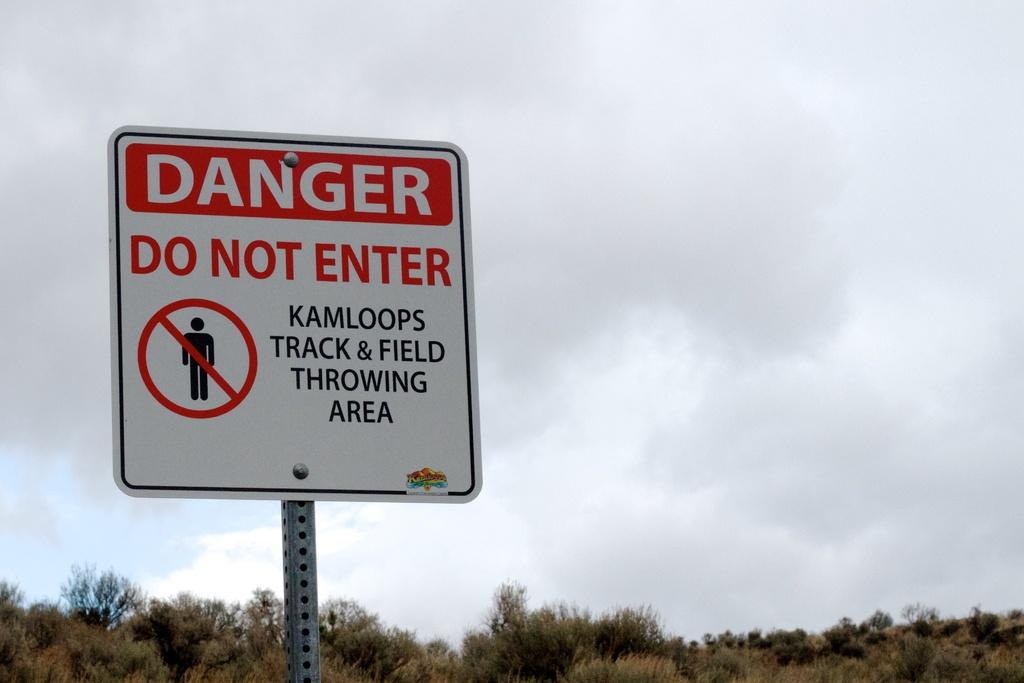<image>
Render a clear and concise summary of the photo. A white sign says "danger, do not enter." 